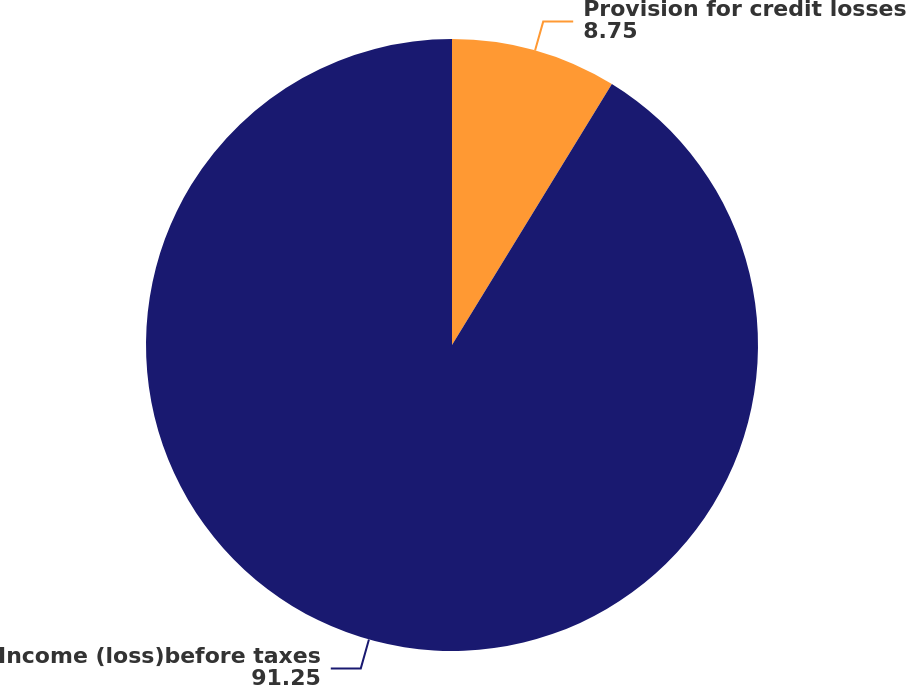Convert chart. <chart><loc_0><loc_0><loc_500><loc_500><pie_chart><fcel>Provision for credit losses<fcel>Income (loss)before taxes<nl><fcel>8.75%<fcel>91.25%<nl></chart> 